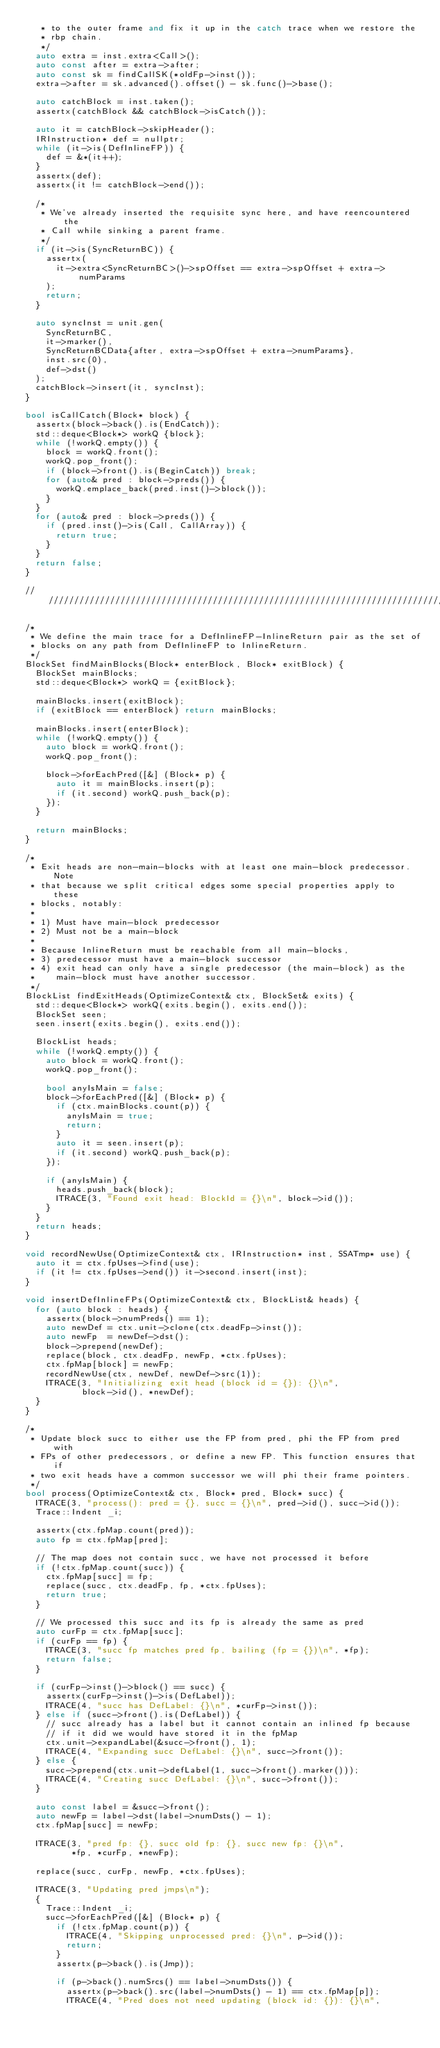<code> <loc_0><loc_0><loc_500><loc_500><_C++_>   * to the outer frame and fix it up in the catch trace when we restore the
   * rbp chain.
   */
  auto extra = inst.extra<Call>();
  auto const after = extra->after;
  auto const sk = findCallSK(*oldFp->inst());
  extra->after = sk.advanced().offset() - sk.func()->base();

  auto catchBlock = inst.taken();
  assertx(catchBlock && catchBlock->isCatch());

  auto it = catchBlock->skipHeader();
  IRInstruction* def = nullptr;
  while (it->is(DefInlineFP)) {
    def = &*(it++);
  }
  assertx(def);
  assertx(it != catchBlock->end());

  /*
   * We've already inserted the requisite sync here, and have reencountered the
   * Call while sinking a parent frame.
   */
  if (it->is(SyncReturnBC)) {
    assertx(
      it->extra<SyncReturnBC>()->spOffset == extra->spOffset + extra->numParams
    );
    return;
  }

  auto syncInst = unit.gen(
    SyncReturnBC,
    it->marker(),
    SyncReturnBCData{after, extra->spOffset + extra->numParams},
    inst.src(0),
    def->dst()
  );
  catchBlock->insert(it, syncInst);
}

bool isCallCatch(Block* block) {
  assertx(block->back().is(EndCatch));
  std::deque<Block*> workQ {block};
  while (!workQ.empty()) {
    block = workQ.front();
    workQ.pop_front();
    if (block->front().is(BeginCatch)) break;
    for (auto& pred : block->preds()) {
      workQ.emplace_back(pred.inst()->block());
    }
  }
  for (auto& pred : block->preds()) {
    if (pred.inst()->is(Call, CallArray)) {
      return true;
    }
  }
  return false;
}

////////////////////////////////////////////////////////////////////////////////

/*
 * We define the main trace for a DefInlineFP-InlineReturn pair as the set of
 * blocks on any path from DefInlineFP to InlineReturn.
 */
BlockSet findMainBlocks(Block* enterBlock, Block* exitBlock) {
  BlockSet mainBlocks;
  std::deque<Block*> workQ = {exitBlock};

  mainBlocks.insert(exitBlock);
  if (exitBlock == enterBlock) return mainBlocks;

  mainBlocks.insert(enterBlock);
  while (!workQ.empty()) {
    auto block = workQ.front();
    workQ.pop_front();

    block->forEachPred([&] (Block* p) {
      auto it = mainBlocks.insert(p);
      if (it.second) workQ.push_back(p);
    });
  }

  return mainBlocks;
}

/*
 * Exit heads are non-main-blocks with at least one main-block predecessor. Note
 * that because we split critical edges some special properties apply to these
 * blocks, notably:
 *
 * 1) Must have main-block predecessor
 * 2) Must not be a main-block
 *
 * Because InlineReturn must be reachable from all main-blocks,
 * 3) predecessor must have a main-block successor
 * 4) exit head can only have a single predecessor (the main-block) as the
 *    main-block must have another successor.
 */
BlockList findExitHeads(OptimizeContext& ctx, BlockSet& exits) {
  std::deque<Block*> workQ(exits.begin(), exits.end());
  BlockSet seen;
  seen.insert(exits.begin(), exits.end());

  BlockList heads;
  while (!workQ.empty()) {
    auto block = workQ.front();
    workQ.pop_front();

    bool anyIsMain = false;
    block->forEachPred([&] (Block* p) {
      if (ctx.mainBlocks.count(p)) {
        anyIsMain = true;
        return;
      }
      auto it = seen.insert(p);
      if (it.second) workQ.push_back(p);
    });

    if (anyIsMain) {
      heads.push_back(block);
      ITRACE(3, "Found exit head: BlockId = {}\n", block->id());
    }
  }
  return heads;
}

void recordNewUse(OptimizeContext& ctx, IRInstruction* inst, SSATmp* use) {
  auto it = ctx.fpUses->find(use);
  if (it != ctx.fpUses->end()) it->second.insert(inst);
}

void insertDefInlineFPs(OptimizeContext& ctx, BlockList& heads) {
  for (auto block : heads) {
    assertx(block->numPreds() == 1);
    auto newDef = ctx.unit->clone(ctx.deadFp->inst());
    auto newFp  = newDef->dst();
    block->prepend(newDef);
    replace(block, ctx.deadFp, newFp, *ctx.fpUses);
    ctx.fpMap[block] = newFp;
    recordNewUse(ctx, newDef, newDef->src(1));
    ITRACE(3, "Initializing exit head (block id = {}): {}\n",
           block->id(), *newDef);
  }
}

/*
 * Update block succ to either use the FP from pred, phi the FP from pred with
 * FPs of other predecessors, or define a new FP. This function ensures that if
 * two exit heads have a common successor we will phi their frame pointers.
 */
bool process(OptimizeContext& ctx, Block* pred, Block* succ) {
  ITRACE(3, "process(): pred = {}, succ = {}\n", pred->id(), succ->id());
  Trace::Indent _i;

  assertx(ctx.fpMap.count(pred));
  auto fp = ctx.fpMap[pred];

  // The map does not contain succ, we have not processed it before
  if (!ctx.fpMap.count(succ)) {
    ctx.fpMap[succ] = fp;
    replace(succ, ctx.deadFp, fp, *ctx.fpUses);
    return true;
  }

  // We processed this succ and its fp is already the same as pred
  auto curFp = ctx.fpMap[succ];
  if (curFp == fp) {
    ITRACE(3, "succ fp matches pred fp, bailing (fp = {})\n", *fp);
    return false;
  }

  if (curFp->inst()->block() == succ) {
    assertx(curFp->inst()->is(DefLabel));
    ITRACE(4, "succ has DefLabel: {}\n", *curFp->inst());
  } else if (succ->front().is(DefLabel)) {
    // succ already has a label but it cannot contain an inlined fp because
    // if it did we would have stored it in the fpMap
    ctx.unit->expandLabel(&succ->front(), 1);
    ITRACE(4, "Expanding succ DefLabel: {}\n", succ->front());
  } else {
    succ->prepend(ctx.unit->defLabel(1, succ->front().marker()));
    ITRACE(4, "Creating succ DefLabel: {}\n", succ->front());
  }

  auto const label = &succ->front();
  auto newFp = label->dst(label->numDsts() - 1);
  ctx.fpMap[succ] = newFp;

  ITRACE(3, "pred fp: {}, succ old fp: {}, succ new fp: {}\n",
         *fp, *curFp, *newFp);

  replace(succ, curFp, newFp, *ctx.fpUses);

  ITRACE(3, "Updating pred jmps\n");
  {
    Trace::Indent _i;
    succ->forEachPred([&] (Block* p) {
      if (!ctx.fpMap.count(p)) {
        ITRACE(4, "Skipping unprocessed pred: {}\n", p->id());
        return;
      }
      assertx(p->back().is(Jmp));

      if (p->back().numSrcs() == label->numDsts()) {
        assertx(p->back().src(label->numDsts() - 1) == ctx.fpMap[p]);
        ITRACE(4, "Pred does not need updating (block id: {}): {}\n",</code> 